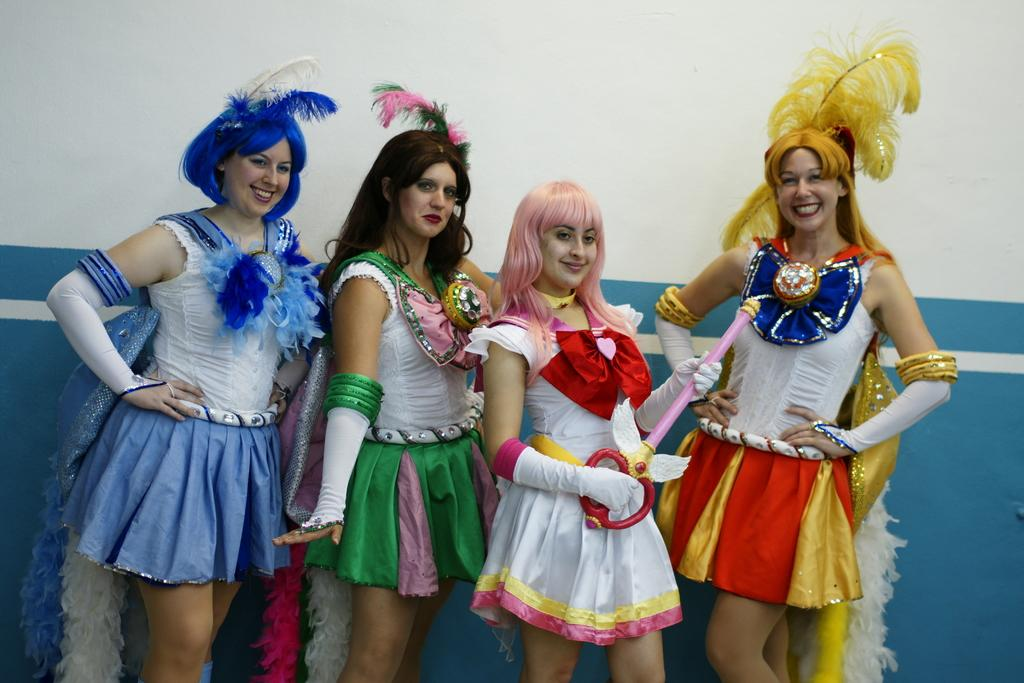Who is present in the image? There are women in the image. What expression do the women have? The women are smiling. What are the women wearing in the image? The women are dressed in costumes. What type of cave can be seen in the background of the image? There is no cave present in the image; it features women dressed in costumes and smiling. 